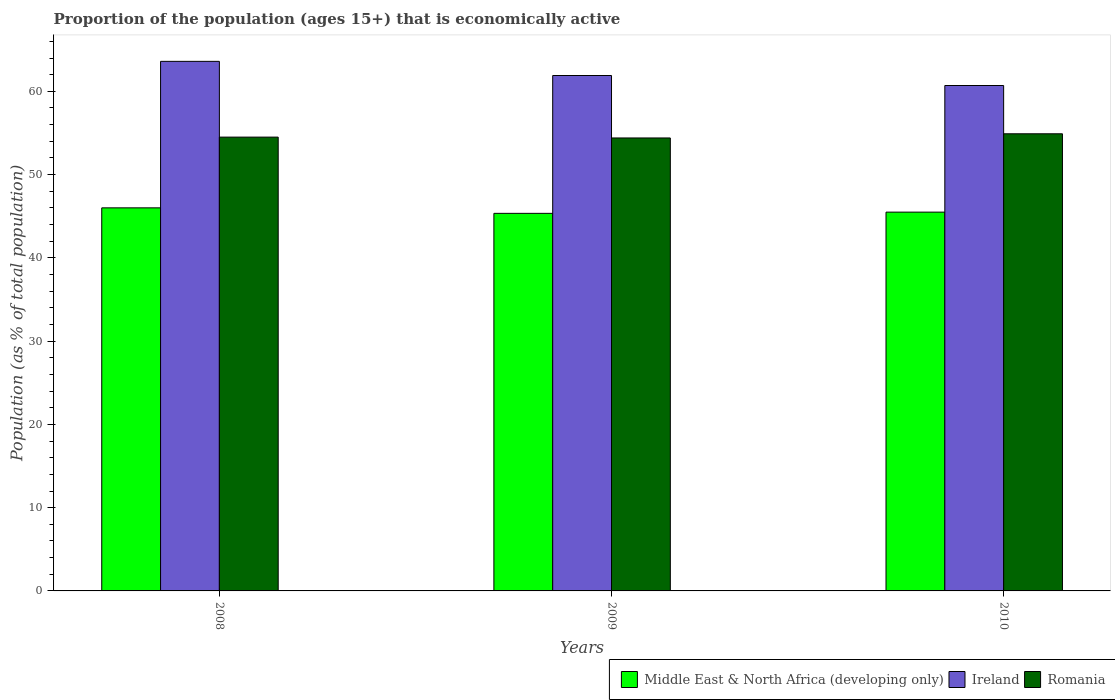Are the number of bars per tick equal to the number of legend labels?
Keep it short and to the point. Yes. How many bars are there on the 2nd tick from the right?
Give a very brief answer. 3. What is the label of the 1st group of bars from the left?
Ensure brevity in your answer.  2008. In how many cases, is the number of bars for a given year not equal to the number of legend labels?
Provide a short and direct response. 0. What is the proportion of the population that is economically active in Romania in 2008?
Your answer should be very brief. 54.5. Across all years, what is the maximum proportion of the population that is economically active in Ireland?
Offer a very short reply. 63.6. Across all years, what is the minimum proportion of the population that is economically active in Middle East & North Africa (developing only)?
Provide a short and direct response. 45.34. In which year was the proportion of the population that is economically active in Romania maximum?
Your answer should be very brief. 2010. In which year was the proportion of the population that is economically active in Romania minimum?
Make the answer very short. 2009. What is the total proportion of the population that is economically active in Middle East & North Africa (developing only) in the graph?
Offer a terse response. 136.84. What is the difference between the proportion of the population that is economically active in Ireland in 2008 and that in 2009?
Make the answer very short. 1.7. What is the difference between the proportion of the population that is economically active in Middle East & North Africa (developing only) in 2008 and the proportion of the population that is economically active in Ireland in 2009?
Provide a succinct answer. -15.89. What is the average proportion of the population that is economically active in Middle East & North Africa (developing only) per year?
Give a very brief answer. 45.61. In the year 2008, what is the difference between the proportion of the population that is economically active in Romania and proportion of the population that is economically active in Ireland?
Provide a short and direct response. -9.1. What is the ratio of the proportion of the population that is economically active in Middle East & North Africa (developing only) in 2008 to that in 2009?
Keep it short and to the point. 1.01. What is the difference between the highest and the second highest proportion of the population that is economically active in Middle East & North Africa (developing only)?
Provide a short and direct response. 0.52. Is the sum of the proportion of the population that is economically active in Romania in 2008 and 2009 greater than the maximum proportion of the population that is economically active in Ireland across all years?
Provide a succinct answer. Yes. What does the 3rd bar from the left in 2008 represents?
Provide a succinct answer. Romania. What does the 3rd bar from the right in 2010 represents?
Offer a very short reply. Middle East & North Africa (developing only). Is it the case that in every year, the sum of the proportion of the population that is economically active in Middle East & North Africa (developing only) and proportion of the population that is economically active in Romania is greater than the proportion of the population that is economically active in Ireland?
Your answer should be compact. Yes. How many bars are there?
Offer a terse response. 9. What is the difference between two consecutive major ticks on the Y-axis?
Your answer should be very brief. 10. Are the values on the major ticks of Y-axis written in scientific E-notation?
Make the answer very short. No. Does the graph contain grids?
Your answer should be very brief. No. Where does the legend appear in the graph?
Provide a succinct answer. Bottom right. What is the title of the graph?
Your answer should be very brief. Proportion of the population (ages 15+) that is economically active. What is the label or title of the Y-axis?
Offer a very short reply. Population (as % of total population). What is the Population (as % of total population) in Middle East & North Africa (developing only) in 2008?
Your answer should be very brief. 46.01. What is the Population (as % of total population) of Ireland in 2008?
Give a very brief answer. 63.6. What is the Population (as % of total population) in Romania in 2008?
Make the answer very short. 54.5. What is the Population (as % of total population) in Middle East & North Africa (developing only) in 2009?
Provide a succinct answer. 45.34. What is the Population (as % of total population) of Ireland in 2009?
Provide a short and direct response. 61.9. What is the Population (as % of total population) of Romania in 2009?
Your answer should be very brief. 54.4. What is the Population (as % of total population) of Middle East & North Africa (developing only) in 2010?
Give a very brief answer. 45.49. What is the Population (as % of total population) in Ireland in 2010?
Ensure brevity in your answer.  60.7. What is the Population (as % of total population) in Romania in 2010?
Provide a succinct answer. 54.9. Across all years, what is the maximum Population (as % of total population) in Middle East & North Africa (developing only)?
Your answer should be compact. 46.01. Across all years, what is the maximum Population (as % of total population) of Ireland?
Make the answer very short. 63.6. Across all years, what is the maximum Population (as % of total population) of Romania?
Your answer should be very brief. 54.9. Across all years, what is the minimum Population (as % of total population) of Middle East & North Africa (developing only)?
Ensure brevity in your answer.  45.34. Across all years, what is the minimum Population (as % of total population) of Ireland?
Give a very brief answer. 60.7. Across all years, what is the minimum Population (as % of total population) of Romania?
Offer a very short reply. 54.4. What is the total Population (as % of total population) of Middle East & North Africa (developing only) in the graph?
Offer a very short reply. 136.84. What is the total Population (as % of total population) of Ireland in the graph?
Your response must be concise. 186.2. What is the total Population (as % of total population) of Romania in the graph?
Your response must be concise. 163.8. What is the difference between the Population (as % of total population) of Middle East & North Africa (developing only) in 2008 and that in 2009?
Make the answer very short. 0.66. What is the difference between the Population (as % of total population) of Middle East & North Africa (developing only) in 2008 and that in 2010?
Offer a terse response. 0.52. What is the difference between the Population (as % of total population) of Ireland in 2008 and that in 2010?
Make the answer very short. 2.9. What is the difference between the Population (as % of total population) of Romania in 2008 and that in 2010?
Your answer should be compact. -0.4. What is the difference between the Population (as % of total population) in Middle East & North Africa (developing only) in 2009 and that in 2010?
Provide a short and direct response. -0.15. What is the difference between the Population (as % of total population) of Romania in 2009 and that in 2010?
Your answer should be compact. -0.5. What is the difference between the Population (as % of total population) in Middle East & North Africa (developing only) in 2008 and the Population (as % of total population) in Ireland in 2009?
Give a very brief answer. -15.89. What is the difference between the Population (as % of total population) in Middle East & North Africa (developing only) in 2008 and the Population (as % of total population) in Romania in 2009?
Your answer should be compact. -8.39. What is the difference between the Population (as % of total population) of Middle East & North Africa (developing only) in 2008 and the Population (as % of total population) of Ireland in 2010?
Offer a terse response. -14.69. What is the difference between the Population (as % of total population) of Middle East & North Africa (developing only) in 2008 and the Population (as % of total population) of Romania in 2010?
Your response must be concise. -8.89. What is the difference between the Population (as % of total population) in Middle East & North Africa (developing only) in 2009 and the Population (as % of total population) in Ireland in 2010?
Give a very brief answer. -15.36. What is the difference between the Population (as % of total population) in Middle East & North Africa (developing only) in 2009 and the Population (as % of total population) in Romania in 2010?
Offer a terse response. -9.56. What is the difference between the Population (as % of total population) in Ireland in 2009 and the Population (as % of total population) in Romania in 2010?
Your answer should be compact. 7. What is the average Population (as % of total population) of Middle East & North Africa (developing only) per year?
Make the answer very short. 45.61. What is the average Population (as % of total population) of Ireland per year?
Provide a short and direct response. 62.07. What is the average Population (as % of total population) of Romania per year?
Ensure brevity in your answer.  54.6. In the year 2008, what is the difference between the Population (as % of total population) in Middle East & North Africa (developing only) and Population (as % of total population) in Ireland?
Offer a terse response. -17.59. In the year 2008, what is the difference between the Population (as % of total population) of Middle East & North Africa (developing only) and Population (as % of total population) of Romania?
Offer a terse response. -8.49. In the year 2008, what is the difference between the Population (as % of total population) in Ireland and Population (as % of total population) in Romania?
Offer a very short reply. 9.1. In the year 2009, what is the difference between the Population (as % of total population) in Middle East & North Africa (developing only) and Population (as % of total population) in Ireland?
Your answer should be very brief. -16.56. In the year 2009, what is the difference between the Population (as % of total population) in Middle East & North Africa (developing only) and Population (as % of total population) in Romania?
Give a very brief answer. -9.06. In the year 2010, what is the difference between the Population (as % of total population) in Middle East & North Africa (developing only) and Population (as % of total population) in Ireland?
Give a very brief answer. -15.21. In the year 2010, what is the difference between the Population (as % of total population) of Middle East & North Africa (developing only) and Population (as % of total population) of Romania?
Give a very brief answer. -9.41. In the year 2010, what is the difference between the Population (as % of total population) of Ireland and Population (as % of total population) of Romania?
Your answer should be very brief. 5.8. What is the ratio of the Population (as % of total population) of Middle East & North Africa (developing only) in 2008 to that in 2009?
Your answer should be very brief. 1.01. What is the ratio of the Population (as % of total population) of Ireland in 2008 to that in 2009?
Your answer should be very brief. 1.03. What is the ratio of the Population (as % of total population) of Romania in 2008 to that in 2009?
Your answer should be compact. 1. What is the ratio of the Population (as % of total population) of Middle East & North Africa (developing only) in 2008 to that in 2010?
Offer a terse response. 1.01. What is the ratio of the Population (as % of total population) in Ireland in 2008 to that in 2010?
Provide a short and direct response. 1.05. What is the ratio of the Population (as % of total population) of Middle East & North Africa (developing only) in 2009 to that in 2010?
Ensure brevity in your answer.  1. What is the ratio of the Population (as % of total population) of Ireland in 2009 to that in 2010?
Offer a terse response. 1.02. What is the ratio of the Population (as % of total population) in Romania in 2009 to that in 2010?
Give a very brief answer. 0.99. What is the difference between the highest and the second highest Population (as % of total population) in Middle East & North Africa (developing only)?
Give a very brief answer. 0.52. What is the difference between the highest and the second highest Population (as % of total population) in Ireland?
Keep it short and to the point. 1.7. What is the difference between the highest and the lowest Population (as % of total population) of Middle East & North Africa (developing only)?
Offer a very short reply. 0.66. What is the difference between the highest and the lowest Population (as % of total population) of Romania?
Provide a succinct answer. 0.5. 